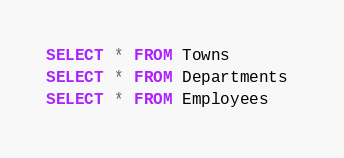<code> <loc_0><loc_0><loc_500><loc_500><_SQL_>SELECT * FROM Towns
SELECT * FROM Departments 
SELECT * FROM Employees 

</code> 